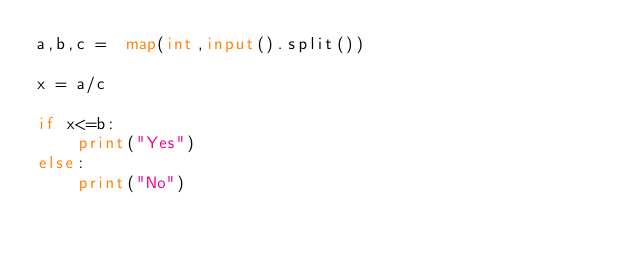<code> <loc_0><loc_0><loc_500><loc_500><_Python_>a,b,c =  map(int,input().split())

x = a/c

if x<=b:
	print("Yes")
else:
	print("No")</code> 